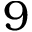<formula> <loc_0><loc_0><loc_500><loc_500>9</formula> 